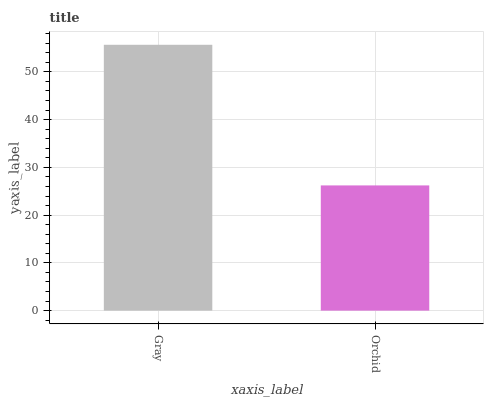Is Orchid the minimum?
Answer yes or no. Yes. Is Gray the maximum?
Answer yes or no. Yes. Is Orchid the maximum?
Answer yes or no. No. Is Gray greater than Orchid?
Answer yes or no. Yes. Is Orchid less than Gray?
Answer yes or no. Yes. Is Orchid greater than Gray?
Answer yes or no. No. Is Gray less than Orchid?
Answer yes or no. No. Is Gray the high median?
Answer yes or no. Yes. Is Orchid the low median?
Answer yes or no. Yes. Is Orchid the high median?
Answer yes or no. No. Is Gray the low median?
Answer yes or no. No. 